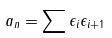<formula> <loc_0><loc_0><loc_500><loc_500>a _ { n } = \sum \epsilon _ { i } \epsilon _ { i + 1 }</formula> 